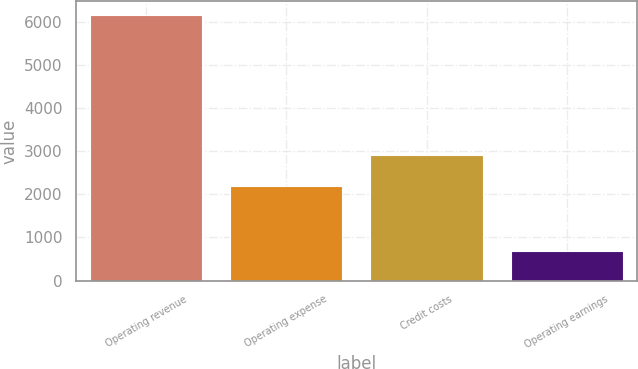Convert chart to OTSL. <chart><loc_0><loc_0><loc_500><loc_500><bar_chart><fcel>Operating revenue<fcel>Operating expense<fcel>Credit costs<fcel>Operating earnings<nl><fcel>6162<fcel>2202<fcel>2904<fcel>679<nl></chart> 